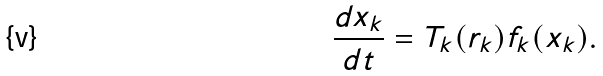<formula> <loc_0><loc_0><loc_500><loc_500>\frac { d x _ { k } } { d t } = T _ { k } ( r _ { k } ) f _ { k } ( x _ { k } ) .</formula> 